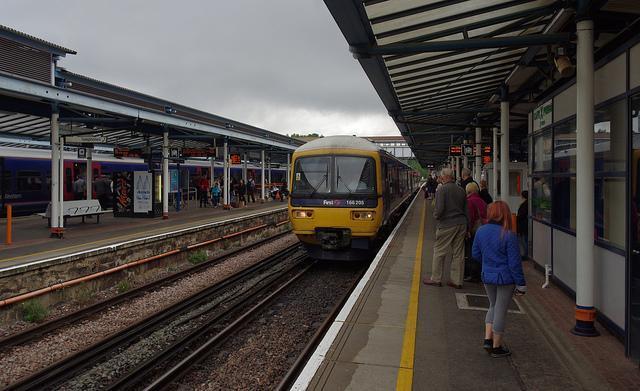How many colors is the train?
Give a very brief answer. 2. How many trains are visible?
Give a very brief answer. 2. How many people are in the picture?
Give a very brief answer. 3. 